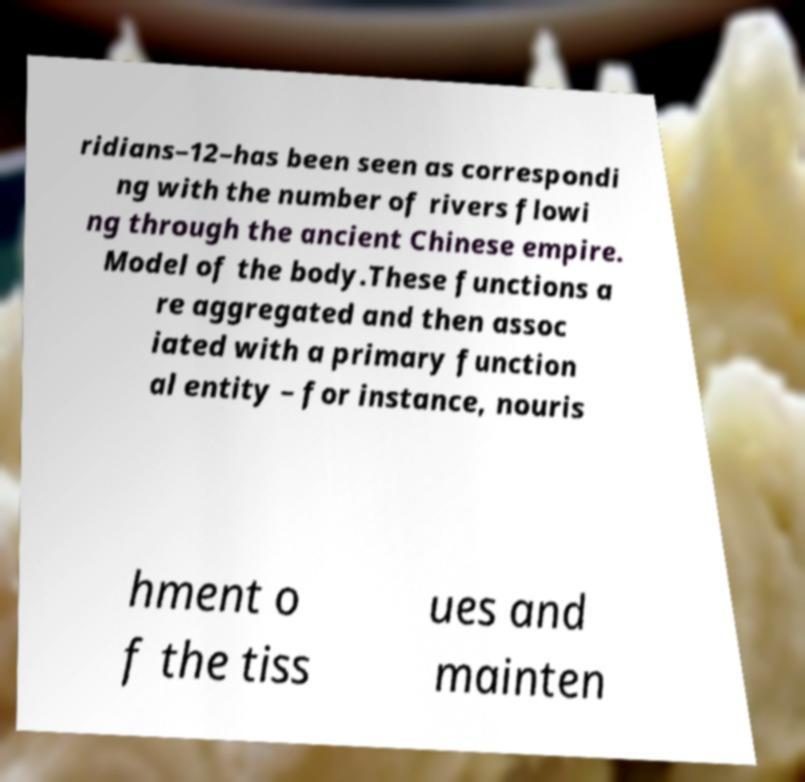Please identify and transcribe the text found in this image. ridians–12–has been seen as correspondi ng with the number of rivers flowi ng through the ancient Chinese empire. Model of the body.These functions a re aggregated and then assoc iated with a primary function al entity – for instance, nouris hment o f the tiss ues and mainten 